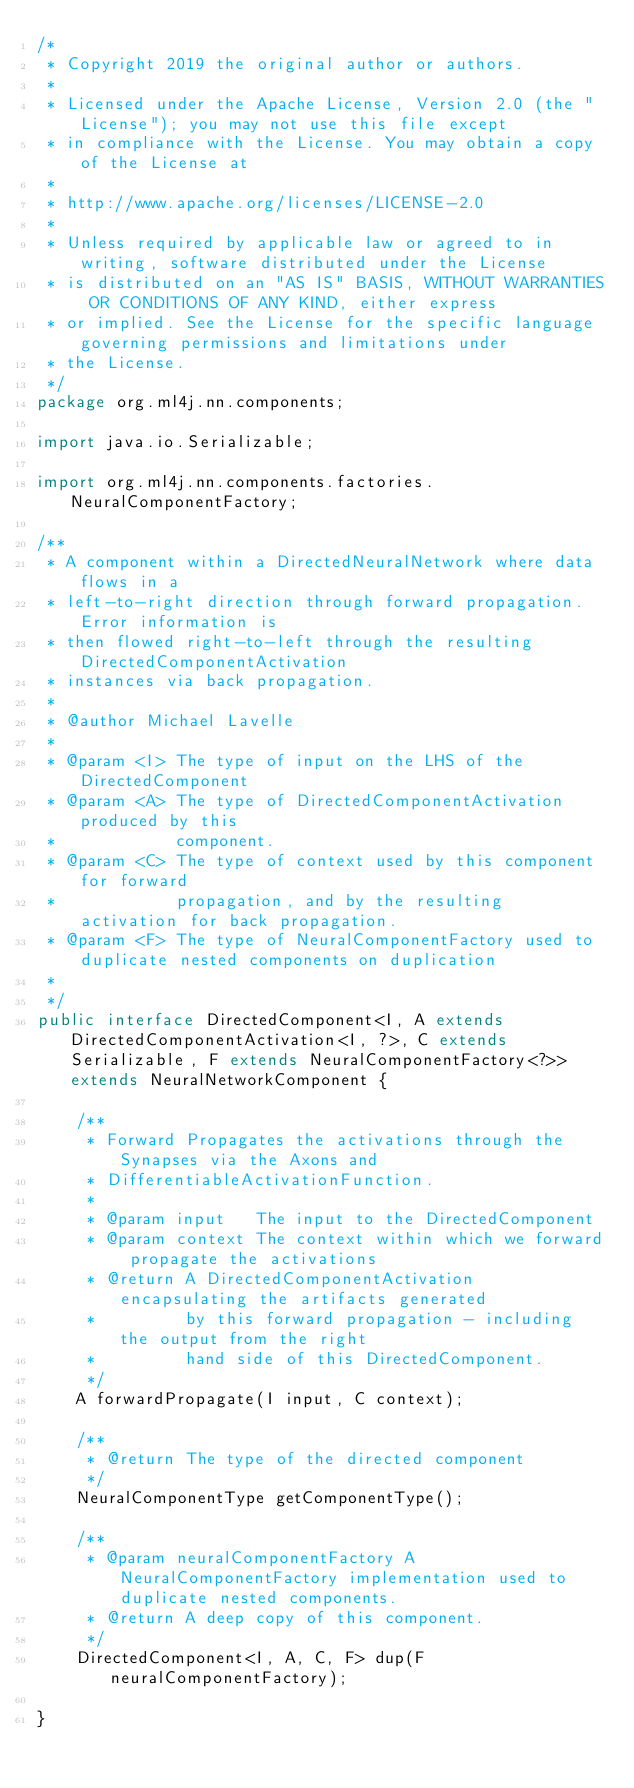Convert code to text. <code><loc_0><loc_0><loc_500><loc_500><_Java_>/*
 * Copyright 2019 the original author or authors.
 *
 * Licensed under the Apache License, Version 2.0 (the "License"); you may not use this file except
 * in compliance with the License. You may obtain a copy of the License at
 *
 * http://www.apache.org/licenses/LICENSE-2.0
 *
 * Unless required by applicable law or agreed to in writing, software distributed under the License
 * is distributed on an "AS IS" BASIS, WITHOUT WARRANTIES OR CONDITIONS OF ANY KIND, either express
 * or implied. See the License for the specific language governing permissions and limitations under
 * the License.
 */
package org.ml4j.nn.components;

import java.io.Serializable;

import org.ml4j.nn.components.factories.NeuralComponentFactory;

/**
 * A component within a DirectedNeuralNetwork where data flows in a
 * left-to-right direction through forward propagation. Error information is
 * then flowed right-to-left through the resulting DirectedComponentActivation
 * instances via back propagation.
 * 
 * @author Michael Lavelle
 *
 * @param <I> The type of input on the LHS of the DirectedComponent
 * @param <A> The type of DirectedComponentActivation produced by this
 *            component.
 * @param <C> The type of context used by this component for forward
 *            propagation, and by the resulting activation for back propagation.
 * @param <F> The type of NeuralComponentFactory used to duplicate nested components on duplication
 * 
 */
public interface DirectedComponent<I, A extends DirectedComponentActivation<I, ?>, C extends Serializable, F extends NeuralComponentFactory<?>> extends NeuralNetworkComponent {

	/**
	 * Forward Propagates the activations through the Synapses via the Axons and
	 * DifferentiableActivationFunction.
	 * 
	 * @param input   The input to the DirectedComponent
	 * @param context The context within which we forward propagate the activations
	 * @return A DirectedComponentActivation encapsulating the artifacts generated
	 *         by this forward propagation - including the output from the right
	 *         hand side of this DirectedComponent.
	 */
	A forwardPropagate(I input, C context);

	/**
	 * @return The type of the directed component
	 */
	NeuralComponentType getComponentType();

	/**
	 * @param neuralComponentFactory A NeuralComponentFactory implementation used to duplicate nested components.
	 * @return A deep copy of this component.
	 */
	DirectedComponent<I, A, C, F> dup(F neuralComponentFactory);

}
</code> 